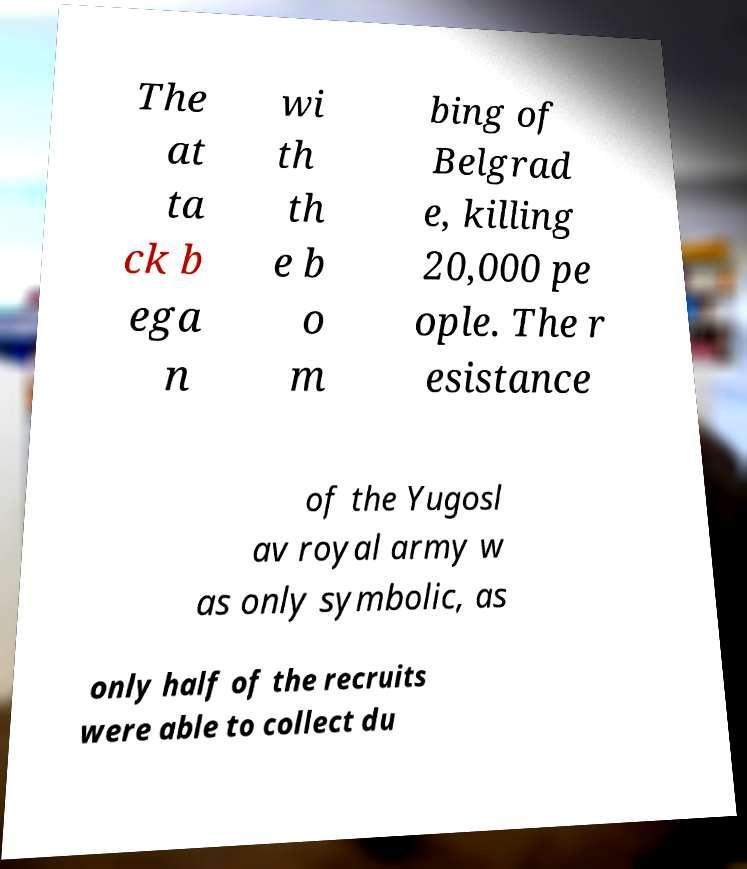Could you extract and type out the text from this image? The at ta ck b ega n wi th th e b o m bing of Belgrad e, killing 20,000 pe ople. The r esistance of the Yugosl av royal army w as only symbolic, as only half of the recruits were able to collect du 